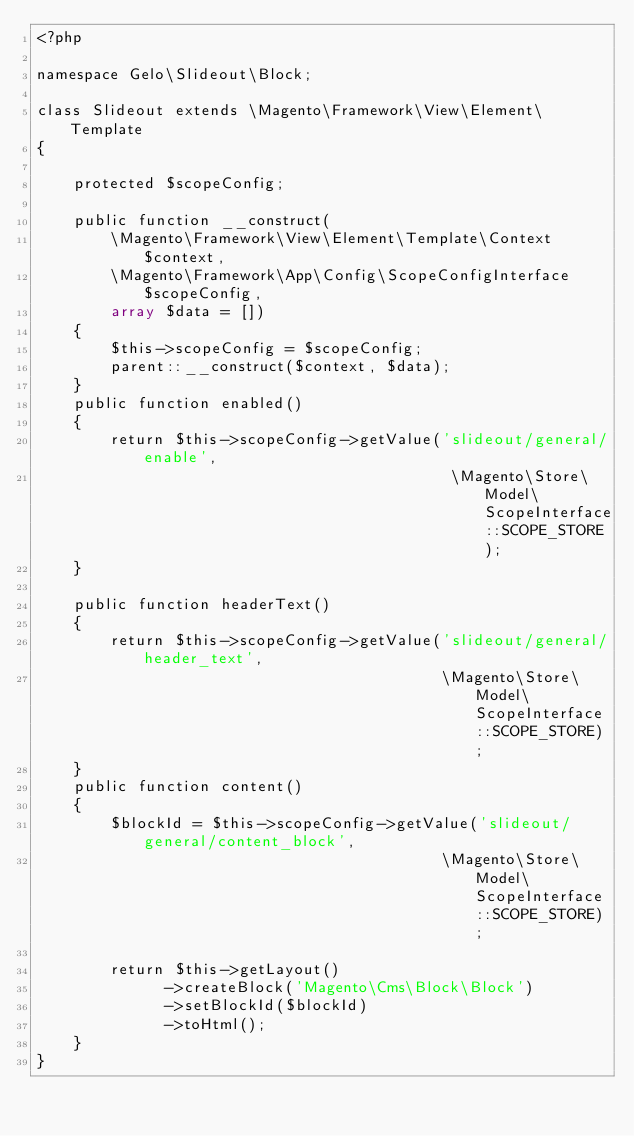Convert code to text. <code><loc_0><loc_0><loc_500><loc_500><_PHP_><?php

namespace Gelo\Slideout\Block;

class Slideout extends \Magento\Framework\View\Element\Template
{

    protected $scopeConfig;
    
    public function __construct(
        \Magento\Framework\View\Element\Template\Context $context,
        \Magento\Framework\App\Config\ScopeConfigInterface $scopeConfig,
        array $data = []) 
    {
        $this->scopeConfig = $scopeConfig;
        parent::__construct($context, $data);
    }  
    public function enabled() 
    {
        return $this->scopeConfig->getValue('slideout/general/enable', 
                                             \Magento\Store\Model\ScopeInterface::SCOPE_STORE);
    }
   
    public function headerText() 
    {
        return $this->scopeConfig->getValue('slideout/general/header_text',
                                            \Magento\Store\Model\ScopeInterface::SCOPE_STORE);
    } 
    public function content() 
    {
        $blockId = $this->scopeConfig->getValue('slideout/general/content_block',
                                            \Magento\Store\Model\ScopeInterface::SCOPE_STORE);
                                                                             
        return $this->getLayout()
              ->createBlock('Magento\Cms\Block\Block')
              ->setBlockId($blockId)
              ->toHtml();
    }
}

</code> 